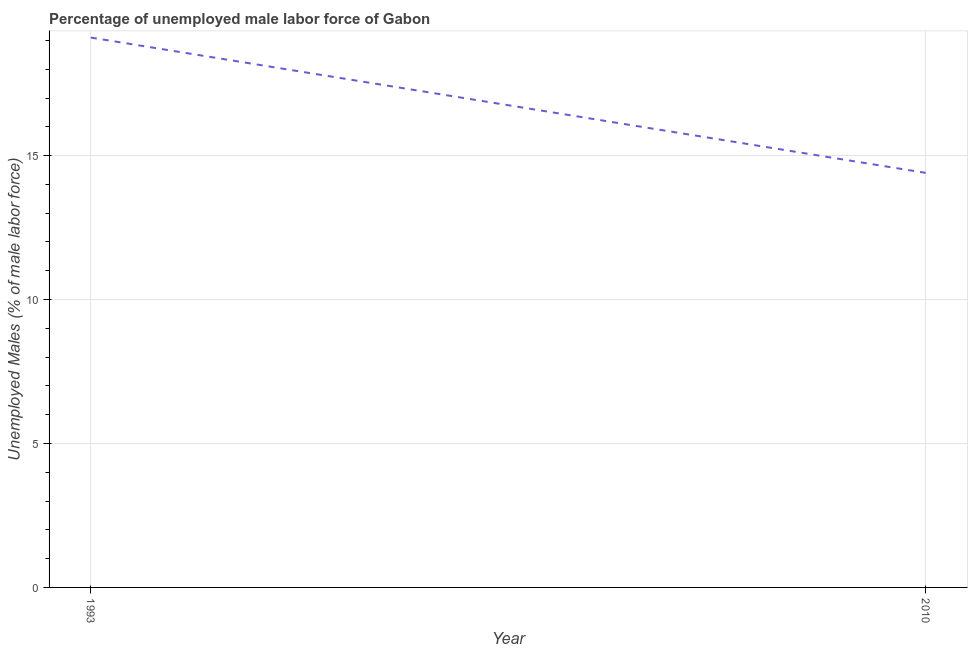What is the total unemployed male labour force in 1993?
Your response must be concise. 19.1. Across all years, what is the maximum total unemployed male labour force?
Keep it short and to the point. 19.1. Across all years, what is the minimum total unemployed male labour force?
Your response must be concise. 14.4. What is the sum of the total unemployed male labour force?
Your answer should be compact. 33.5. What is the difference between the total unemployed male labour force in 1993 and 2010?
Your response must be concise. 4.7. What is the average total unemployed male labour force per year?
Your answer should be very brief. 16.75. What is the median total unemployed male labour force?
Make the answer very short. 16.75. In how many years, is the total unemployed male labour force greater than 17 %?
Give a very brief answer. 1. What is the ratio of the total unemployed male labour force in 1993 to that in 2010?
Give a very brief answer. 1.33. Is the total unemployed male labour force in 1993 less than that in 2010?
Provide a short and direct response. No. In how many years, is the total unemployed male labour force greater than the average total unemployed male labour force taken over all years?
Offer a terse response. 1. Does the total unemployed male labour force monotonically increase over the years?
Your answer should be compact. No. What is the difference between two consecutive major ticks on the Y-axis?
Make the answer very short. 5. Are the values on the major ticks of Y-axis written in scientific E-notation?
Your answer should be very brief. No. Does the graph contain any zero values?
Provide a succinct answer. No. What is the title of the graph?
Provide a short and direct response. Percentage of unemployed male labor force of Gabon. What is the label or title of the X-axis?
Your answer should be compact. Year. What is the label or title of the Y-axis?
Ensure brevity in your answer.  Unemployed Males (% of male labor force). What is the Unemployed Males (% of male labor force) in 1993?
Make the answer very short. 19.1. What is the Unemployed Males (% of male labor force) of 2010?
Provide a succinct answer. 14.4. What is the ratio of the Unemployed Males (% of male labor force) in 1993 to that in 2010?
Ensure brevity in your answer.  1.33. 